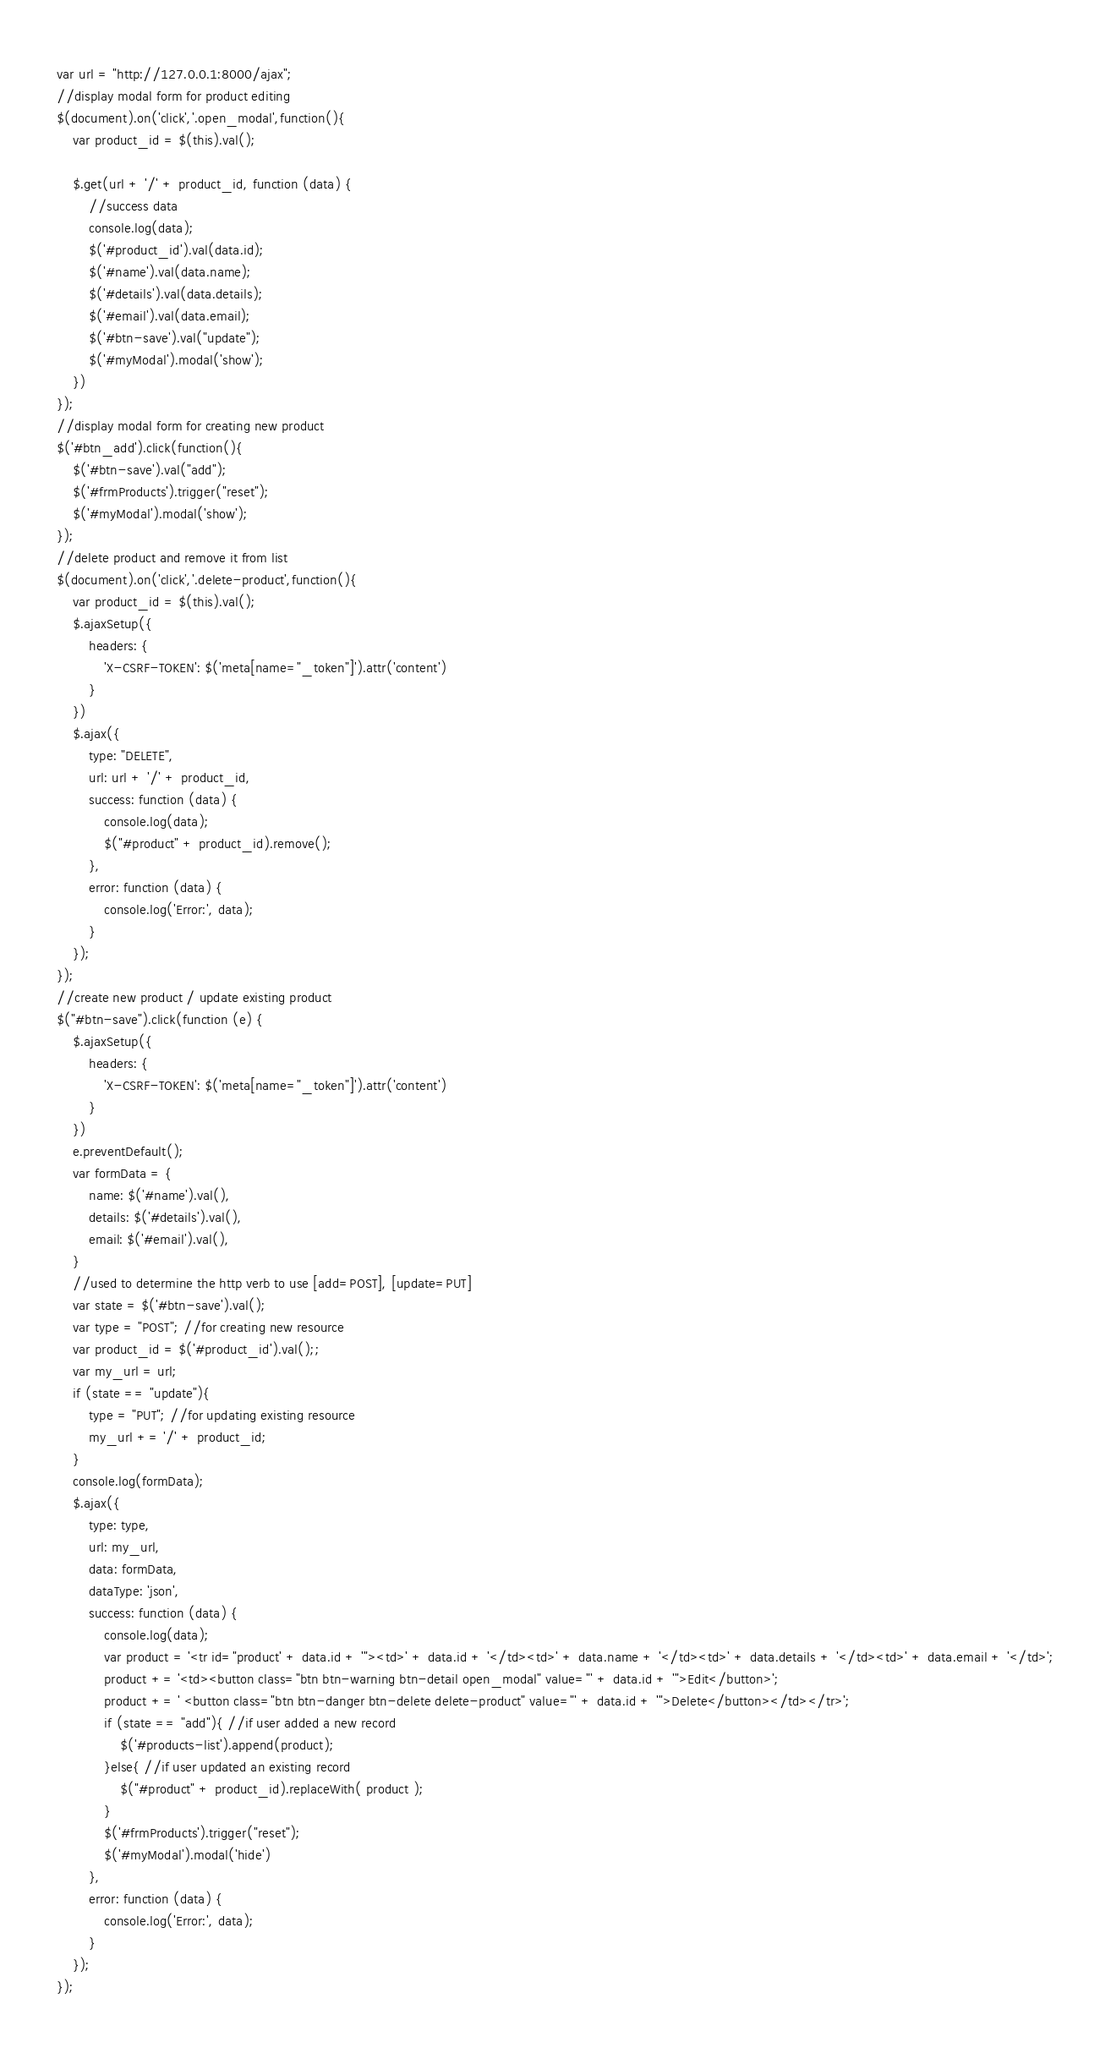Convert code to text. <code><loc_0><loc_0><loc_500><loc_500><_JavaScript_>var url = "http://127.0.0.1:8000/ajax";
//display modal form for product editing
$(document).on('click','.open_modal',function(){
    var product_id = $(this).val();

    $.get(url + '/' + product_id, function (data) {
        //success data
        console.log(data);
        $('#product_id').val(data.id);
        $('#name').val(data.name);
        $('#details').val(data.details);
        $('#email').val(data.email);
        $('#btn-save').val("update");
        $('#myModal').modal('show');
    })
});
//display modal form for creating new product
$('#btn_add').click(function(){
    $('#btn-save').val("add");
    $('#frmProducts').trigger("reset");
    $('#myModal').modal('show');
});
//delete product and remove it from list
$(document).on('click','.delete-product',function(){
    var product_id = $(this).val();
    $.ajaxSetup({
        headers: {
            'X-CSRF-TOKEN': $('meta[name="_token"]').attr('content')
        }
    })
    $.ajax({
        type: "DELETE",
        url: url + '/' + product_id,
        success: function (data) {
            console.log(data);
            $("#product" + product_id).remove();
        },
        error: function (data) {
            console.log('Error:', data);
        }
    });
});
//create new product / update existing product
$("#btn-save").click(function (e) {
    $.ajaxSetup({
        headers: {
            'X-CSRF-TOKEN': $('meta[name="_token"]').attr('content')
        }
    })
    e.preventDefault();
    var formData = {
        name: $('#name').val(),
        details: $('#details').val(),
        email: $('#email').val(),
    }
    //used to determine the http verb to use [add=POST], [update=PUT]
    var state = $('#btn-save').val();
    var type = "POST"; //for creating new resource
    var product_id = $('#product_id').val();;
    var my_url = url;
    if (state == "update"){
        type = "PUT"; //for updating existing resource
        my_url += '/' + product_id;
    }
    console.log(formData);
    $.ajax({
        type: type,
        url: my_url,
        data: formData,
        dataType: 'json',
        success: function (data) {
            console.log(data);
            var product = '<tr id="product' + data.id + '"><td>' + data.id + '</td><td>' + data.name + '</td><td>' + data.details + '</td><td>' + data.email + '</td>';
            product += '<td><button class="btn btn-warning btn-detail open_modal" value="' + data.id + '">Edit</button>';
            product += ' <button class="btn btn-danger btn-delete delete-product" value="' + data.id + '">Delete</button></td></tr>';
            if (state == "add"){ //if user added a new record
                $('#products-list').append(product);
            }else{ //if user updated an existing record
                $("#product" + product_id).replaceWith( product );
            }
            $('#frmProducts').trigger("reset");
            $('#myModal').modal('hide')
        },
        error: function (data) {
            console.log('Error:', data);
        }
    });
});</code> 